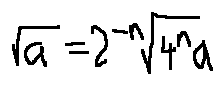<formula> <loc_0><loc_0><loc_500><loc_500>\sqrt { a } = 2 ^ { - n } \sqrt { 4 ^ { n } a }</formula> 